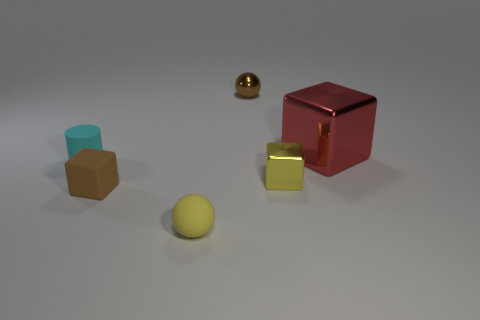What color is the shiny object that is to the left of the large red object and behind the cyan matte cylinder?
Provide a short and direct response. Brown. Is there any other thing that is the same size as the red metal object?
Give a very brief answer. No. Is the number of big metal things in front of the small cyan rubber object greater than the number of matte spheres behind the brown rubber block?
Make the answer very short. No. There is a rubber object in front of the matte block; is it the same size as the brown sphere?
Keep it short and to the point. Yes. What number of cyan objects are left of the cyan rubber thing that is to the left of the small brown thing on the right side of the small matte block?
Your response must be concise. 0. What size is the metallic thing that is both right of the small brown metallic object and behind the small yellow metallic cube?
Keep it short and to the point. Large. What number of other objects are there of the same shape as the tiny cyan matte thing?
Give a very brief answer. 0. How many things are on the left side of the small brown matte object?
Provide a short and direct response. 1. Is the number of small yellow matte things that are in front of the big thing less than the number of big metal blocks behind the matte cylinder?
Provide a succinct answer. No. There is a yellow object that is left of the ball that is behind the yellow matte ball that is to the left of the red metal cube; what is its shape?
Provide a short and direct response. Sphere. 